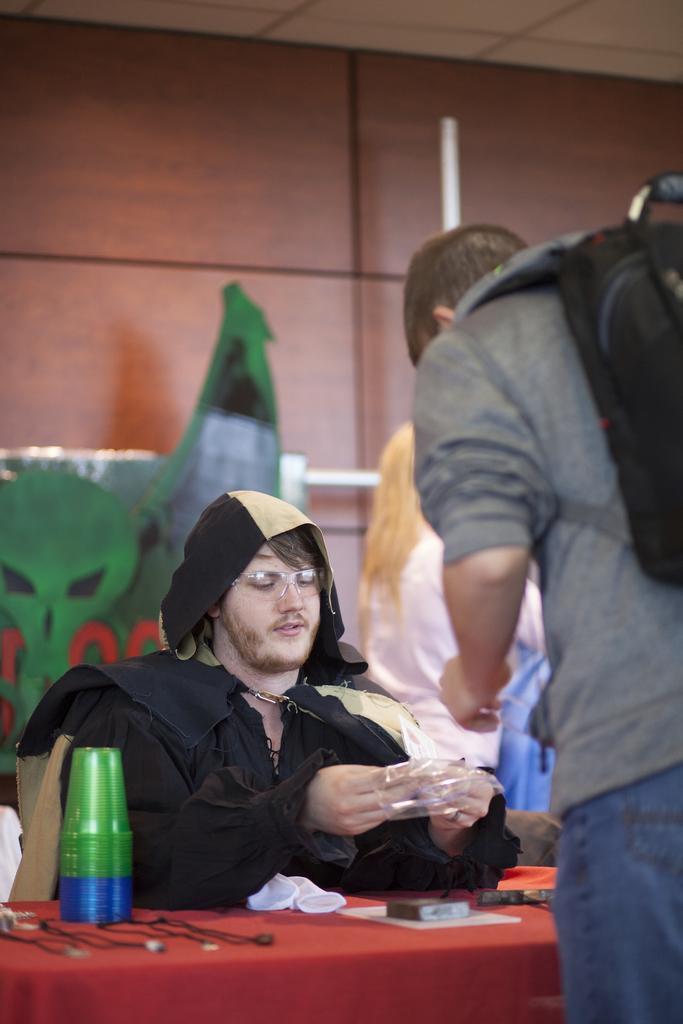How would you summarize this image in a sentence or two? In this image, there are a few people. We can see the table covered with a cloth and some objects like glasses are placed on it. In the background, we can see the wall, a pole and an object. We can also see the roof. 